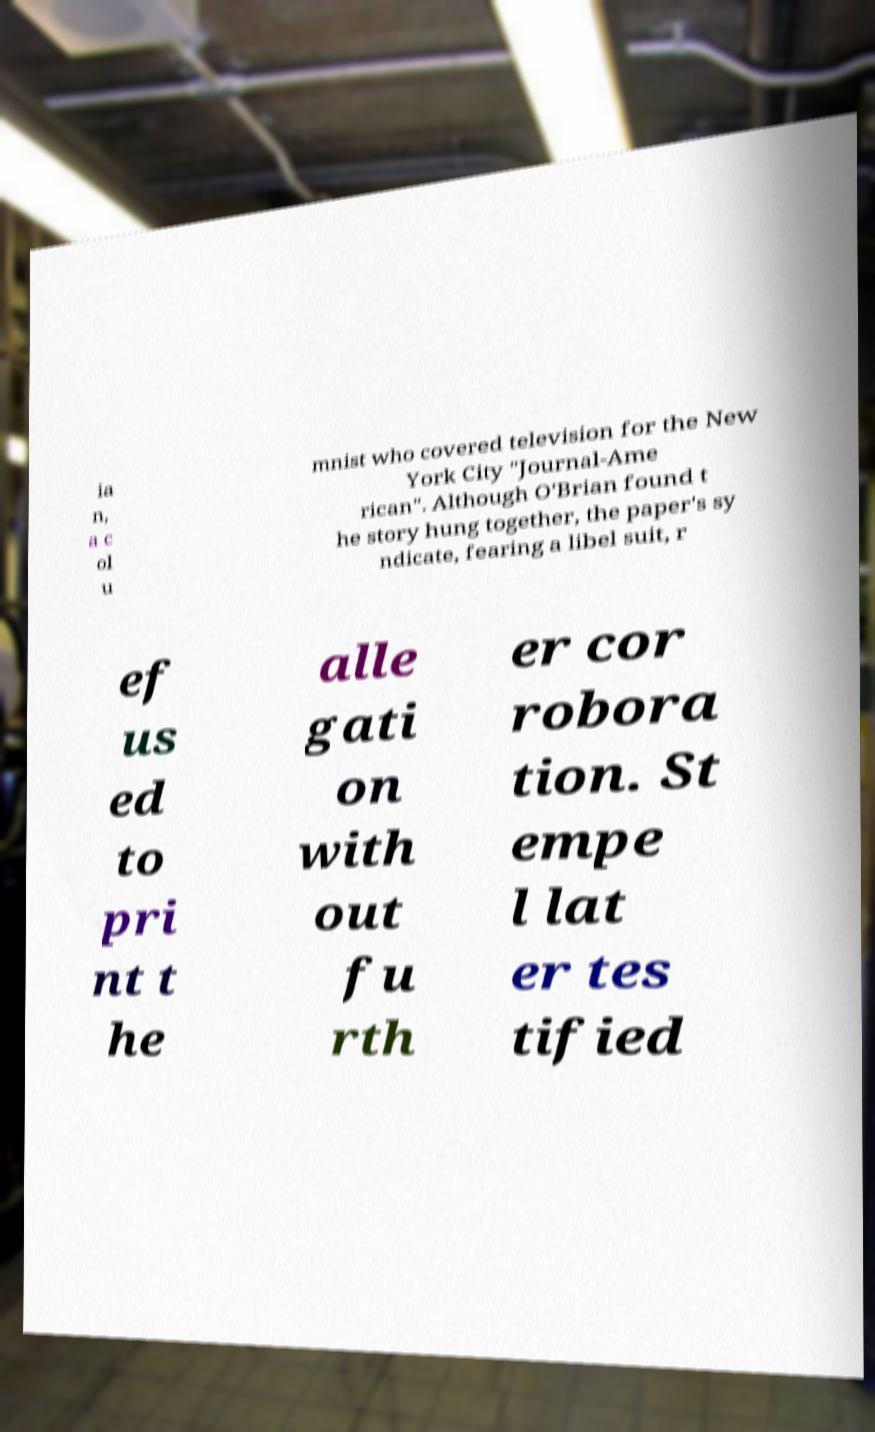Please identify and transcribe the text found in this image. ia n, a c ol u mnist who covered television for the New York City "Journal-Ame rican". Although O'Brian found t he story hung together, the paper's sy ndicate, fearing a libel suit, r ef us ed to pri nt t he alle gati on with out fu rth er cor robora tion. St empe l lat er tes tified 